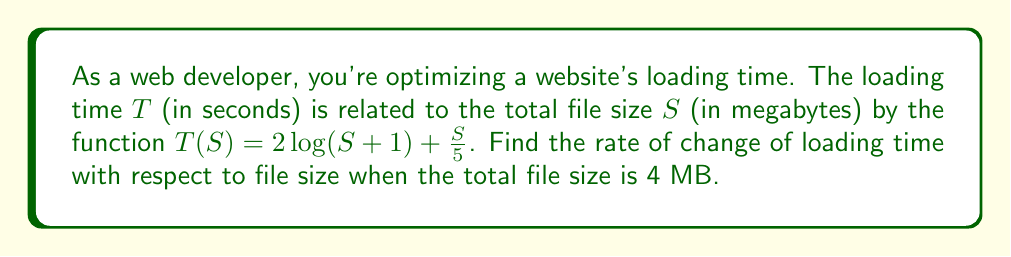Show me your answer to this math problem. To find the rate of change of loading time with respect to file size, we need to calculate the derivative of $T(S)$ and then evaluate it at $S = 4$.

1. Given function: $T(S) = 2\log(S+1) + \frac{S}{5}$

2. Calculate the derivative $\frac{dT}{dS}$ using the sum rule and chain rule:
   $$\frac{dT}{dS} = 2 \cdot \frac{d}{dS}[\log(S+1)] + \frac{d}{dS}[\frac{S}{5}]$$
   $$\frac{dT}{dS} = 2 \cdot \frac{1}{S+1} + \frac{1}{5}$$

3. Simplify:
   $$\frac{dT}{dS} = \frac{2}{S+1} + \frac{1}{5}$$

4. Evaluate at $S = 4$:
   $$\frac{dT}{dS}\bigg|_{S=4} = \frac{2}{4+1} + \frac{1}{5}$$
   $$\frac{dT}{dS}\bigg|_{S=4} = \frac{2}{5} + \frac{1}{5}$$
   $$\frac{dT}{dS}\bigg|_{S=4} = \frac{3}{5} = 0.6$$

This means that when the file size is 4 MB, the loading time is increasing at a rate of 0.6 seconds per MB.
Answer: $0.6$ seconds/MB 